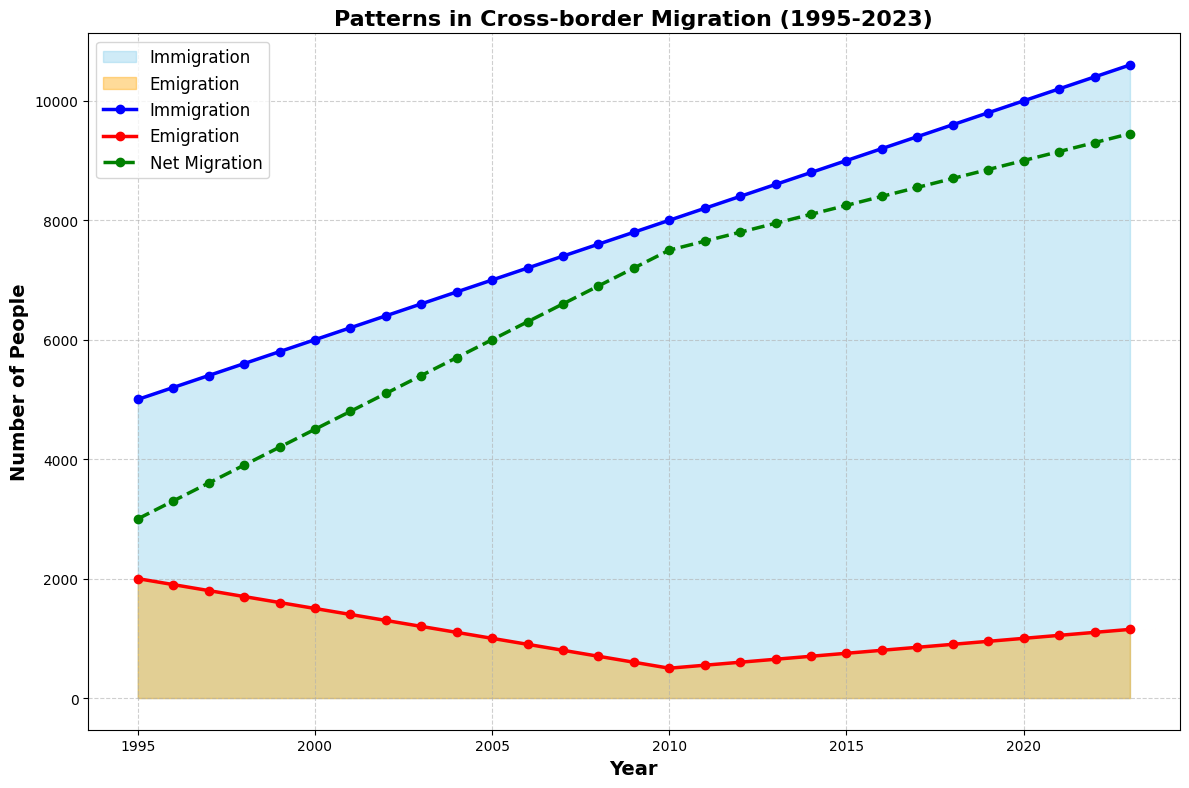What's the trend in immigration from 1995 to 2023? To identify the trend, observe the steady increase in the height of the blue-colored area (representing immigration) from left to right across the period from 1995 to 2023.
Answer: Consistently increasing What year had the highest net migration? Look at the green dashed line (which represents net migration). It reaches its highest point in 2023.
Answer: 2023 How does the emigration number in 2000 compare to 2023? Compare the height of the orange areas corresponding to the years 2000 and 2023. Emigration in 2000 is lower than in 2023.
Answer: Lower in 2000 What is the difference in immigration between 2010 and 2020? Find the point on the blue line for 2010, which is 8000, and the point for 2020, which is 10000. Subtract 8000 from 10000.
Answer: 2000 Which year shows the smallest gap between immigration and emigration? Calculate the difference between the blue line and the red line for each year. The smallest difference occurs in 1995 (5000 - 2000 = 3000).
Answer: 1995 In which year does emigration fall below 1000 and stay below it consistently? Trace the orange area and observe that emigration falls below 1000 in 2005 and stays below it from that year until 2022.
Answer: 2005 How does net migration in 2010 compare to 2005? Refer to the green dashed line at 2010 (7500) and 2005 (6000) and subtract 6000 from 7500.
Answer: 1500 higher What is the average net migration over the first five years (1995-1999)? Sum the net migration values for 1995-1999 (3000 + 3300 + 3600 + 3900 + 4200) and divide by 5. (18000 / 5 = 3600)
Answer: 3600 By how much did immigration grow from 1995 to 1998? Subtract the immigration value in 1995 (5000) from the value in 1998 (5600). 5600 - 5000 = 600
Answer: 600 What is the notable shift in migration patterns post-2005? Observe the plot and notice both immigration and net migration continually rise significantly after 2005, while emigration declines. This indicates an increase in overall migration and a decrease in people leaving.
Answer: Increase in immigration, decrease in emigration 